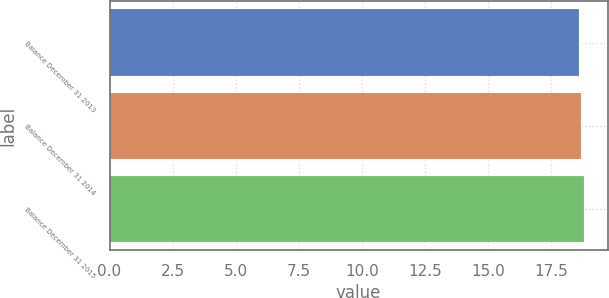Convert chart. <chart><loc_0><loc_0><loc_500><loc_500><bar_chart><fcel>Balance December 31 2013<fcel>Balance December 31 2014<fcel>Balance December 31 2015<nl><fcel>18.6<fcel>18.7<fcel>18.8<nl></chart> 